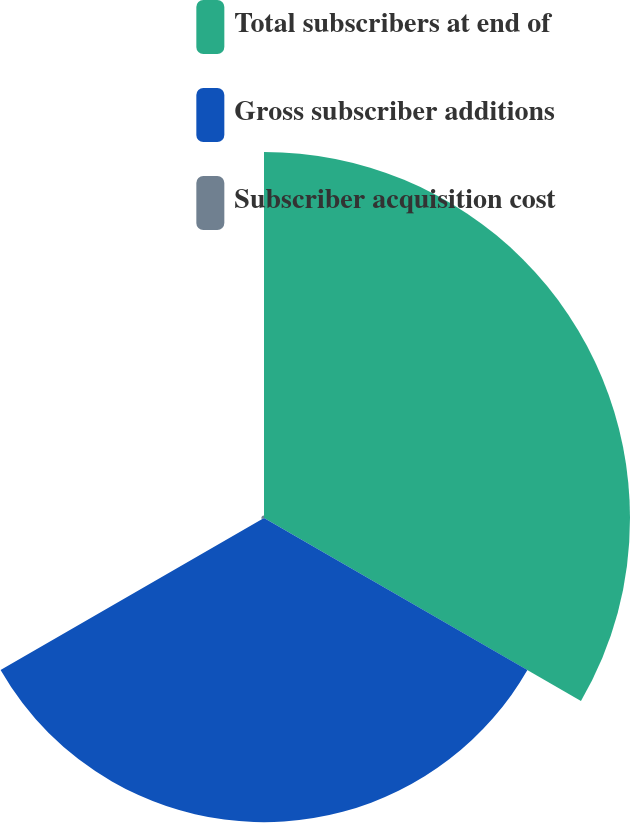Convert chart to OTSL. <chart><loc_0><loc_0><loc_500><loc_500><pie_chart><fcel>Total subscribers at end of<fcel>Gross subscriber additions<fcel>Subscriber acquisition cost<nl><fcel>54.41%<fcel>45.22%<fcel>0.37%<nl></chart> 